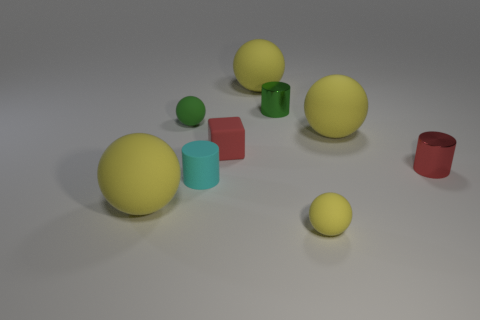If you had to guess, what do you think this image could be used for? This image appears to be a 3D rendering that might be used for a variety of purposes: as a visual exercise in color and shape recognition, a study of light and shadow in renderings, or as an artistic composition. It could also serve educational purposes, illustrating concepts in geometry. Imagine that these objects are part of a game. How could they be used in gameplay? If incorporated into a game, the different shapes and colors could represent various game elements. For instance, they could be used in a matching game where players pair similar colors or shapes, or in a strategy game where each object has different properties and usages based on its geometry, like the cube being a building block and the spheres being elements that could roll to activate paths or mechanisms. 